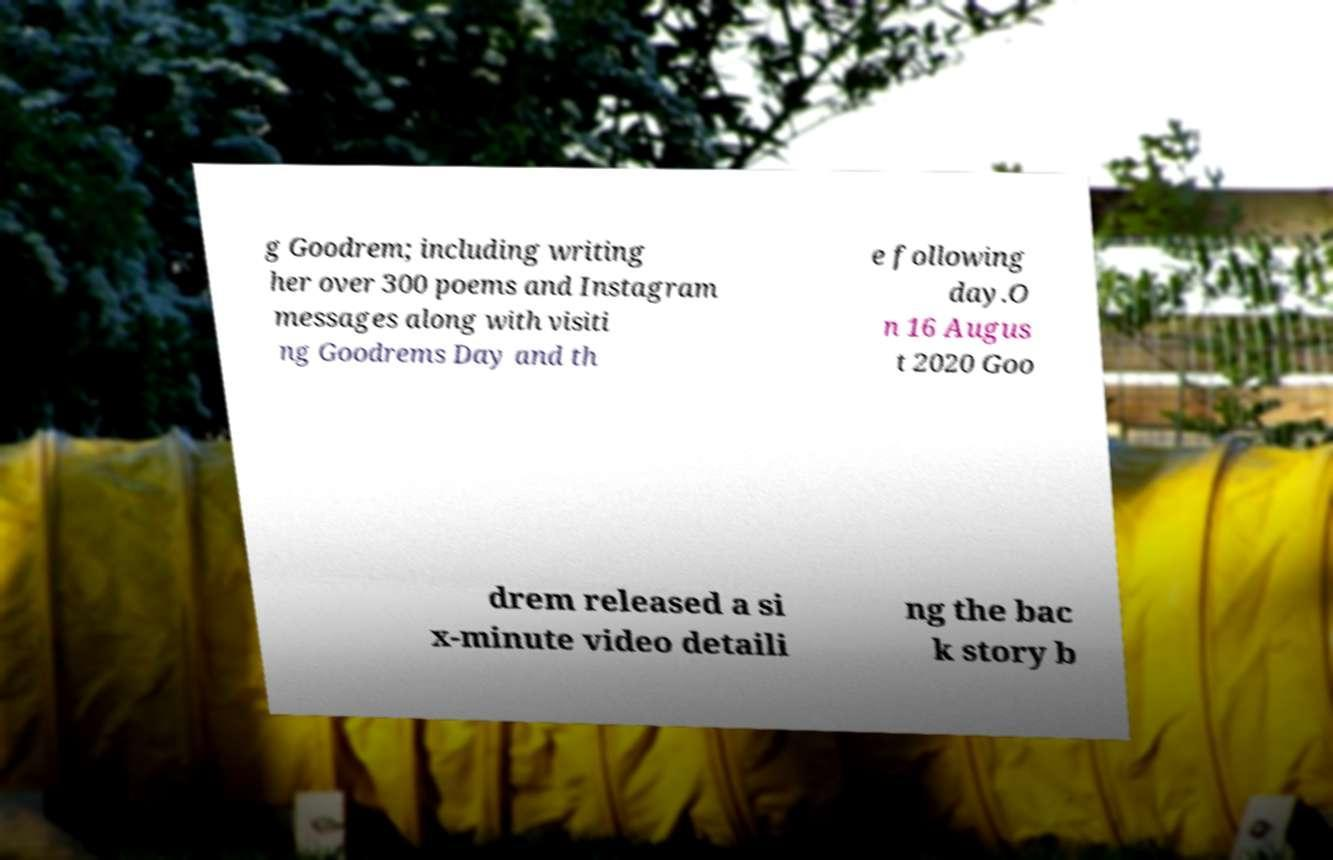Please identify and transcribe the text found in this image. g Goodrem; including writing her over 300 poems and Instagram messages along with visiti ng Goodrems Day and th e following day.O n 16 Augus t 2020 Goo drem released a si x-minute video detaili ng the bac k story b 